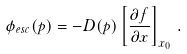<formula> <loc_0><loc_0><loc_500><loc_500>\phi _ { e s c } ( p ) = - D ( p ) \left [ \frac { \partial f } { \partial x } \right ] _ { x _ { 0 } } \, .</formula> 